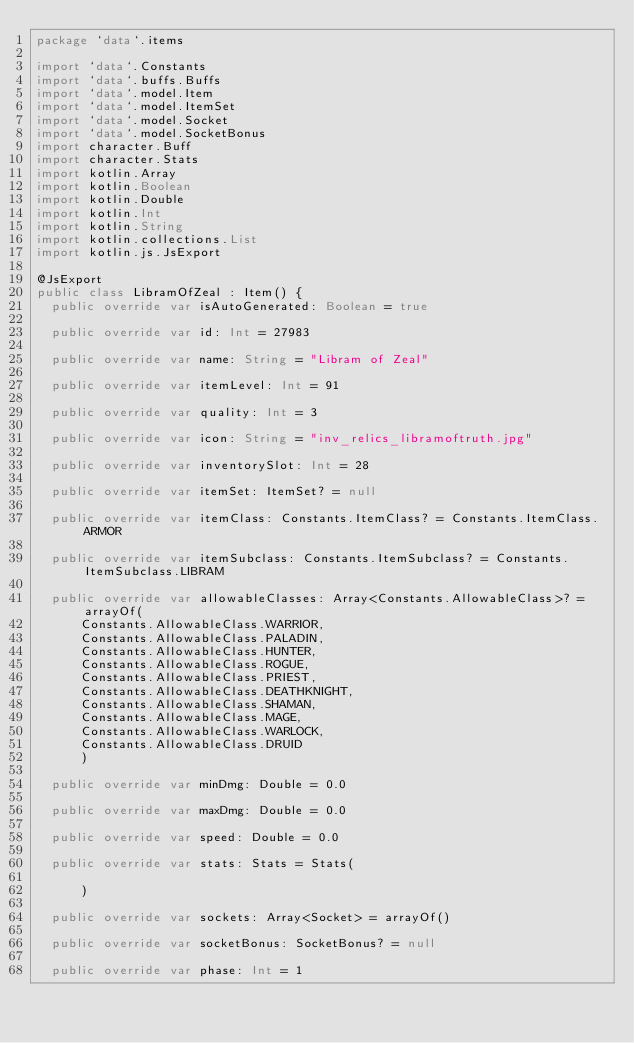<code> <loc_0><loc_0><loc_500><loc_500><_Kotlin_>package `data`.items

import `data`.Constants
import `data`.buffs.Buffs
import `data`.model.Item
import `data`.model.ItemSet
import `data`.model.Socket
import `data`.model.SocketBonus
import character.Buff
import character.Stats
import kotlin.Array
import kotlin.Boolean
import kotlin.Double
import kotlin.Int
import kotlin.String
import kotlin.collections.List
import kotlin.js.JsExport

@JsExport
public class LibramOfZeal : Item() {
  public override var isAutoGenerated: Boolean = true

  public override var id: Int = 27983

  public override var name: String = "Libram of Zeal"

  public override var itemLevel: Int = 91

  public override var quality: Int = 3

  public override var icon: String = "inv_relics_libramoftruth.jpg"

  public override var inventorySlot: Int = 28

  public override var itemSet: ItemSet? = null

  public override var itemClass: Constants.ItemClass? = Constants.ItemClass.ARMOR

  public override var itemSubclass: Constants.ItemSubclass? = Constants.ItemSubclass.LIBRAM

  public override var allowableClasses: Array<Constants.AllowableClass>? = arrayOf(
      Constants.AllowableClass.WARRIOR,
      Constants.AllowableClass.PALADIN,
      Constants.AllowableClass.HUNTER,
      Constants.AllowableClass.ROGUE,
      Constants.AllowableClass.PRIEST,
      Constants.AllowableClass.DEATHKNIGHT,
      Constants.AllowableClass.SHAMAN,
      Constants.AllowableClass.MAGE,
      Constants.AllowableClass.WARLOCK,
      Constants.AllowableClass.DRUID
      )

  public override var minDmg: Double = 0.0

  public override var maxDmg: Double = 0.0

  public override var speed: Double = 0.0

  public override var stats: Stats = Stats(

      )

  public override var sockets: Array<Socket> = arrayOf()

  public override var socketBonus: SocketBonus? = null

  public override var phase: Int = 1
</code> 